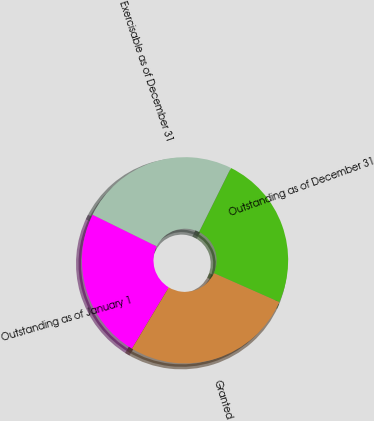Convert chart. <chart><loc_0><loc_0><loc_500><loc_500><pie_chart><fcel>Outstanding as of January 1<fcel>Granted<fcel>Outstanding as of December 31<fcel>Exercisable as of December 31<nl><fcel>23.68%<fcel>26.98%<fcel>24.29%<fcel>25.05%<nl></chart> 